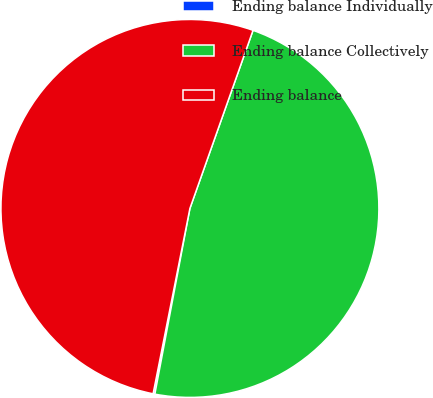Convert chart to OTSL. <chart><loc_0><loc_0><loc_500><loc_500><pie_chart><fcel>Ending balance Individually<fcel>Ending balance Collectively<fcel>Ending balance<nl><fcel>0.15%<fcel>47.55%<fcel>52.3%<nl></chart> 